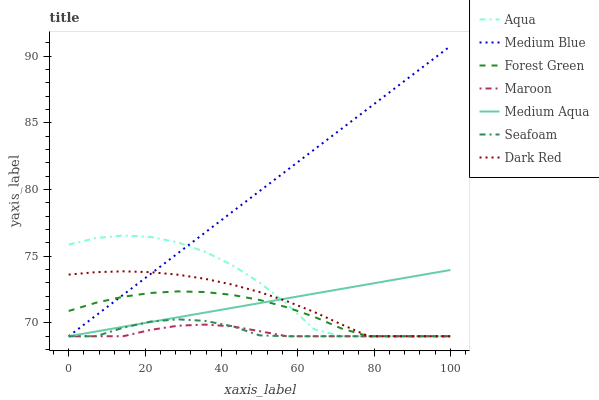Does Maroon have the minimum area under the curve?
Answer yes or no. Yes. Does Medium Blue have the maximum area under the curve?
Answer yes or no. Yes. Does Seafoam have the minimum area under the curve?
Answer yes or no. No. Does Seafoam have the maximum area under the curve?
Answer yes or no. No. Is Medium Aqua the smoothest?
Answer yes or no. Yes. Is Aqua the roughest?
Answer yes or no. Yes. Is Medium Blue the smoothest?
Answer yes or no. No. Is Medium Blue the roughest?
Answer yes or no. No. Does Medium Blue have the highest value?
Answer yes or no. Yes. Does Seafoam have the highest value?
Answer yes or no. No. Does Maroon intersect Aqua?
Answer yes or no. Yes. Is Maroon less than Aqua?
Answer yes or no. No. Is Maroon greater than Aqua?
Answer yes or no. No. 